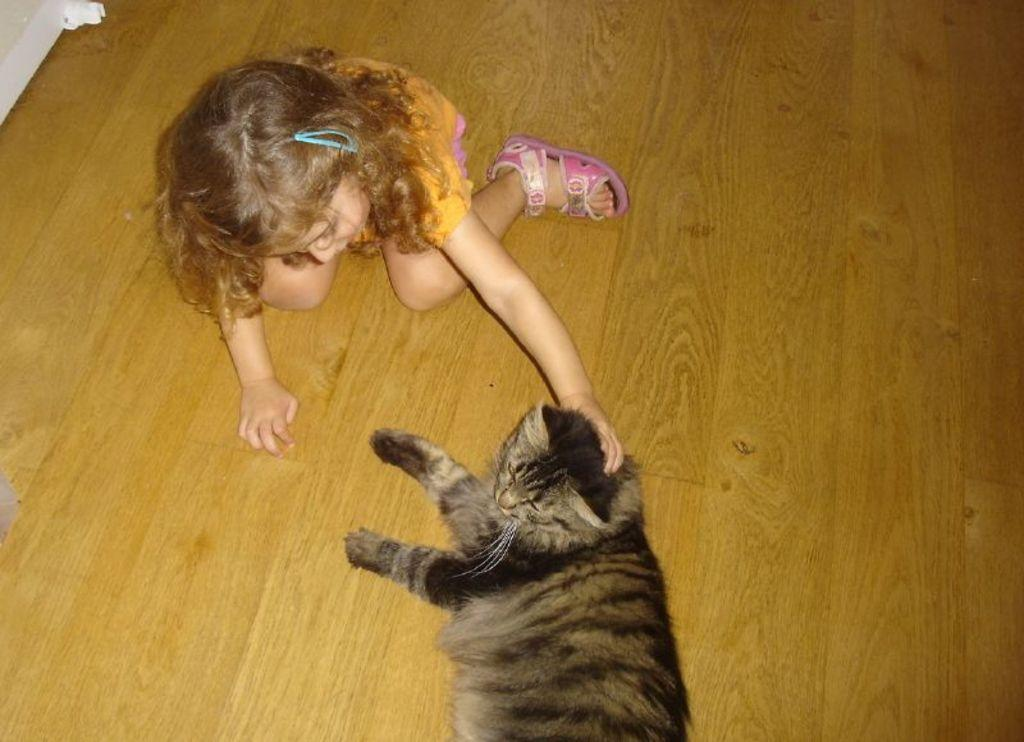Who is present in the image? There is a girl in the image. What is the girl doing in the image? The girl is touching a cat in the image. Where are the girl and the cat located in the image? Both the girl and the cat are on the floor in the image. Where is the nest of the cat in the image? There is no nest present in the image; the cat is simply being touched by the girl on the floor. 